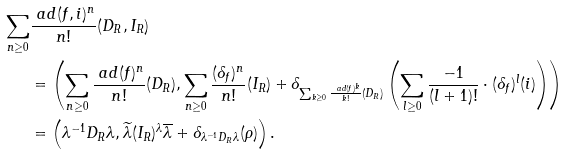<formula> <loc_0><loc_0><loc_500><loc_500>\sum _ { n \geq 0 } & \frac { \ a d ( f , i ) ^ { n } } { n ! } ( D _ { R } , I _ { R } ) \\ & = \left ( \sum _ { n \geq 0 } \frac { \ a d ( f ) ^ { n } } { n ! } ( D _ { R } ) , \sum _ { n \geq 0 } \frac { ( \delta _ { f } ) ^ { n } } { n ! } ( I _ { R } ) + \delta _ { \sum _ { k \geq 0 } \frac { \ a d ( f ) ^ { k } } { k ! } ( D _ { R } ) } \left ( \sum _ { l \geq 0 } \frac { - 1 } { ( l + 1 ) ! } \cdot ( \delta _ { f } ) ^ { l } ( i ) \right ) \right ) \\ & = \left ( \lambda ^ { - 1 } D _ { R } \lambda , \widetilde { \lambda } ( I _ { R } ) ^ { \lambda } \overline { \lambda } + \delta _ { \lambda ^ { - 1 } D _ { R } \lambda } ( \rho ) \right ) .</formula> 